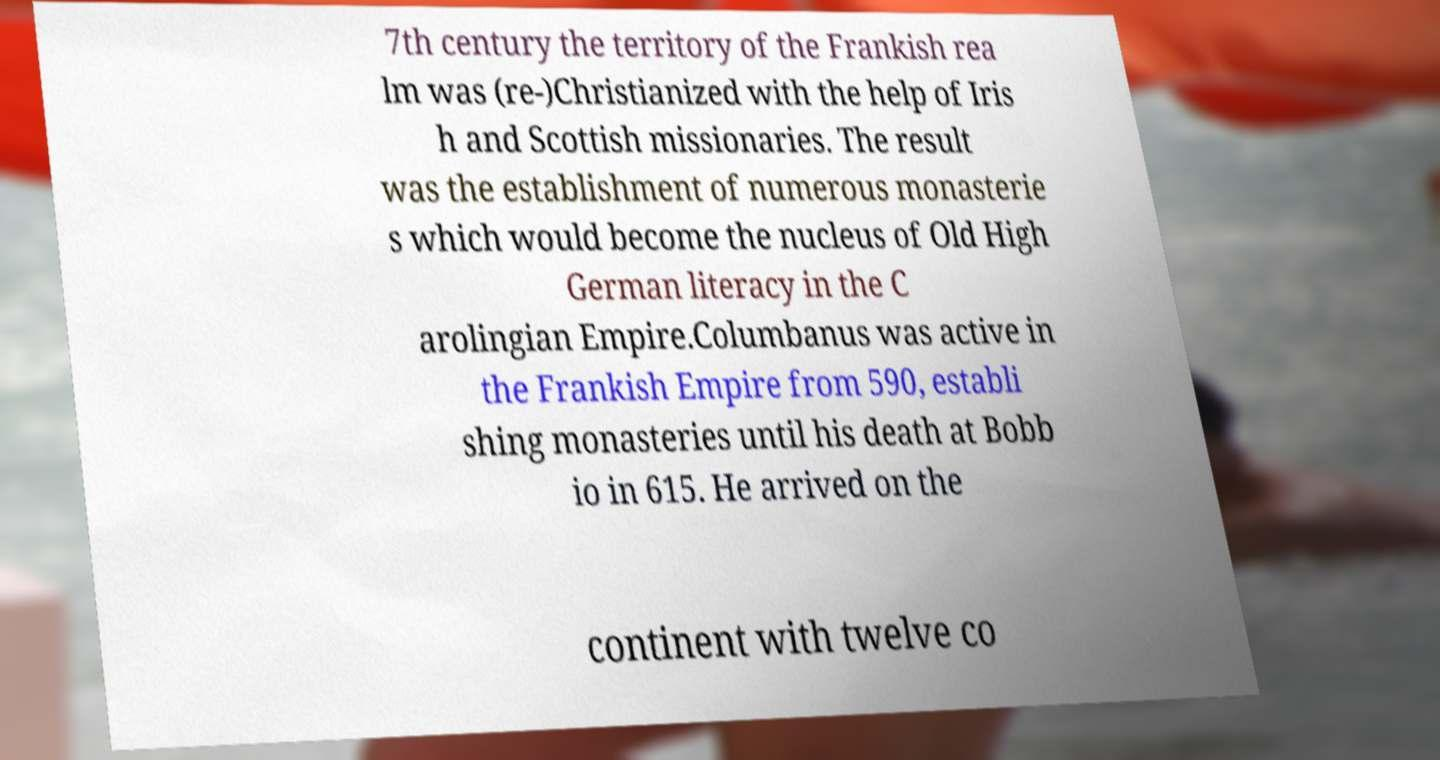Please read and relay the text visible in this image. What does it say? 7th century the territory of the Frankish rea lm was (re-)Christianized with the help of Iris h and Scottish missionaries. The result was the establishment of numerous monasterie s which would become the nucleus of Old High German literacy in the C arolingian Empire.Columbanus was active in the Frankish Empire from 590, establi shing monasteries until his death at Bobb io in 615. He arrived on the continent with twelve co 